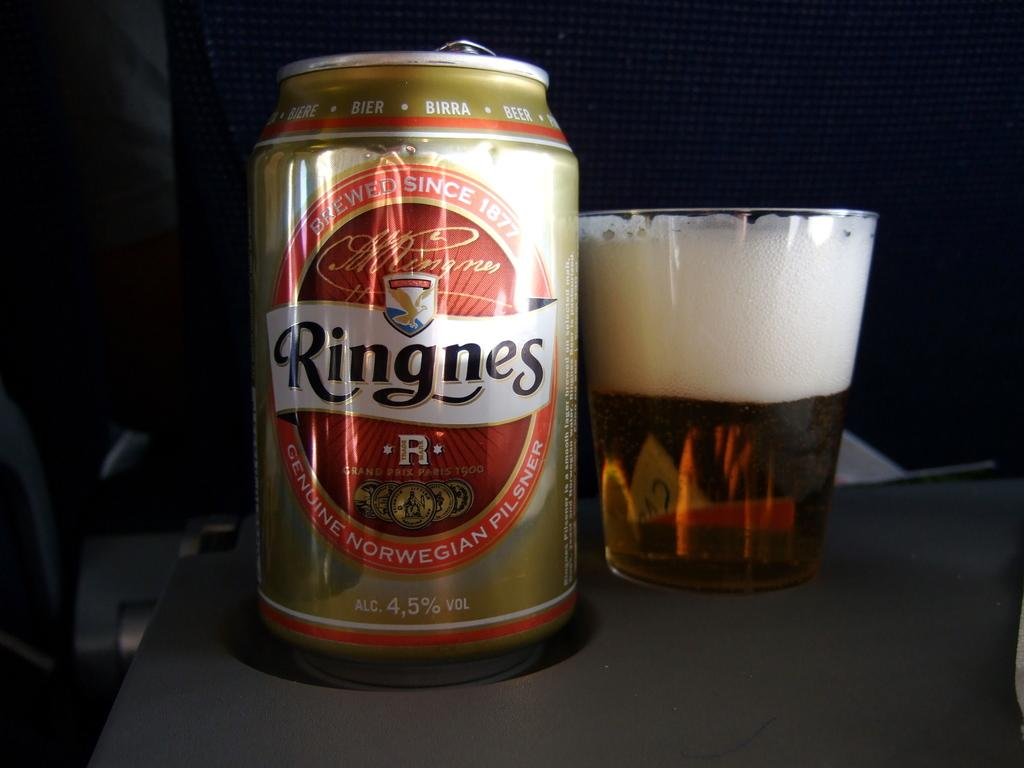<image>
Render a clear and concise summary of the photo. A can of Ringnes norwegian beer next to a glass. 